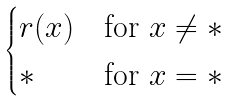<formula> <loc_0><loc_0><loc_500><loc_500>\begin{cases} r ( x ) & \text {for } x \not = * \\ * & \text {for } x = * \end{cases}</formula> 